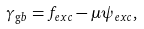<formula> <loc_0><loc_0><loc_500><loc_500>\gamma _ { \mathrm g b } = f _ { e x c } - \mu \psi _ { e x c } ,</formula> 